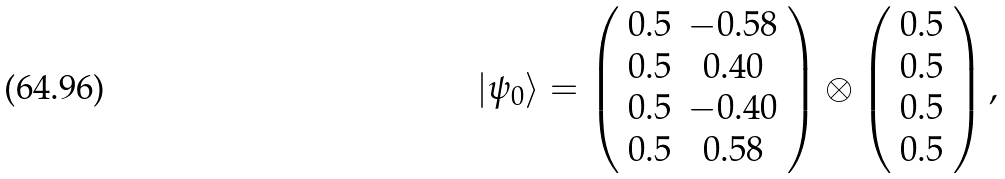Convert formula to latex. <formula><loc_0><loc_0><loc_500><loc_500>| \psi _ { 0 } \rangle = \left ( \begin{array} { c c } 0 . 5 & - 0 . 5 8 \\ 0 . 5 & 0 . 4 0 \\ 0 . 5 & - 0 . 4 0 \\ 0 . 5 & 0 . 5 8 \end{array} \right ) \otimes \left ( \begin{array} { c } 0 . 5 \\ 0 . 5 \\ 0 . 5 \\ 0 . 5 \end{array} \right ) ,</formula> 